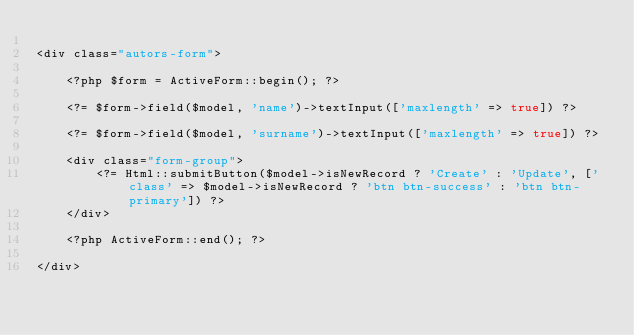Convert code to text. <code><loc_0><loc_0><loc_500><loc_500><_PHP_>
<div class="autors-form">

    <?php $form = ActiveForm::begin(); ?>

    <?= $form->field($model, 'name')->textInput(['maxlength' => true]) ?>

    <?= $form->field($model, 'surname')->textInput(['maxlength' => true]) ?>

    <div class="form-group">
        <?= Html::submitButton($model->isNewRecord ? 'Create' : 'Update', ['class' => $model->isNewRecord ? 'btn btn-success' : 'btn btn-primary']) ?>
    </div>

    <?php ActiveForm::end(); ?>

</div>
</code> 